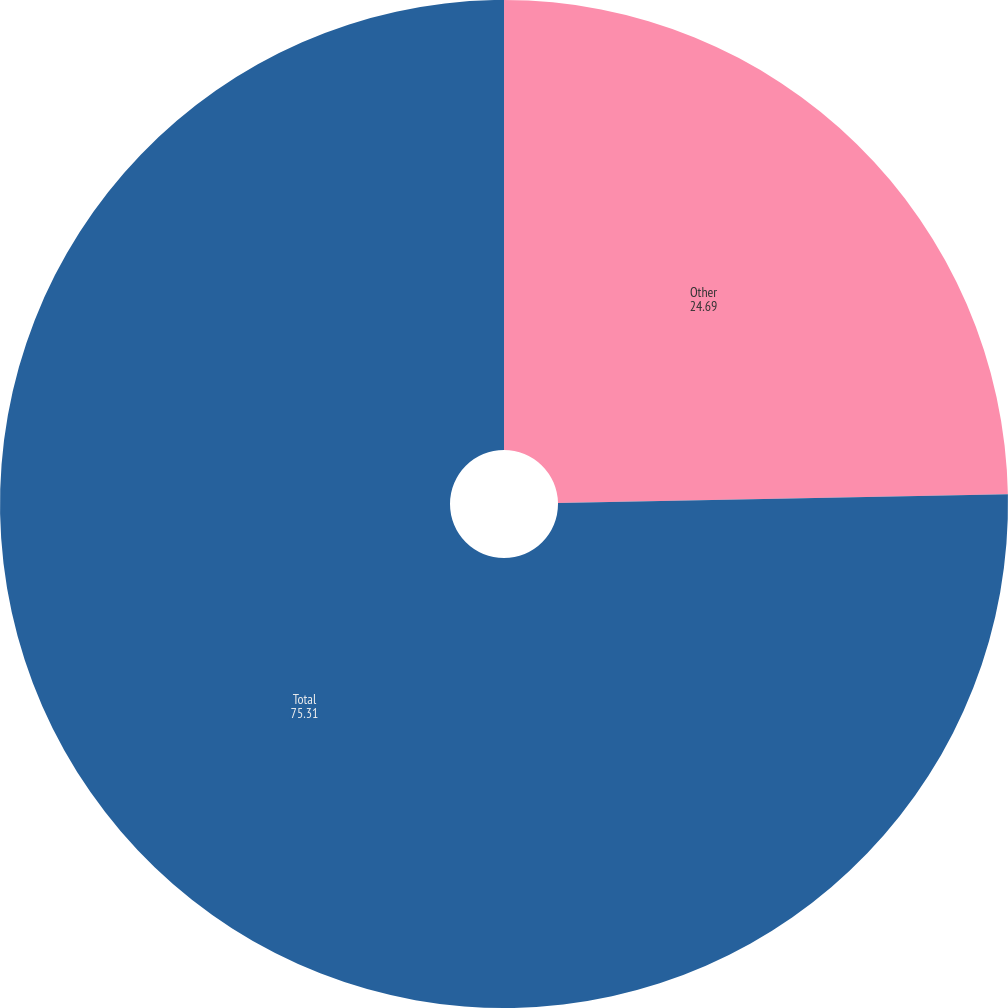Convert chart. <chart><loc_0><loc_0><loc_500><loc_500><pie_chart><fcel>Other<fcel>Total<nl><fcel>24.69%<fcel>75.31%<nl></chart> 